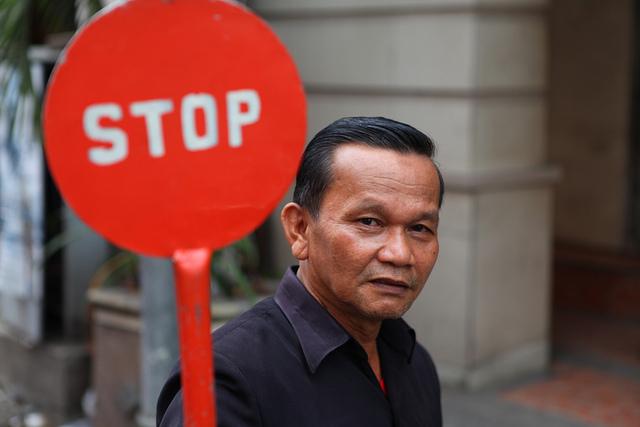Is the man in uniform?
Answer briefly. No. What color is the sign?
Short answer required. Red. Should we go?
Answer briefly. No. 